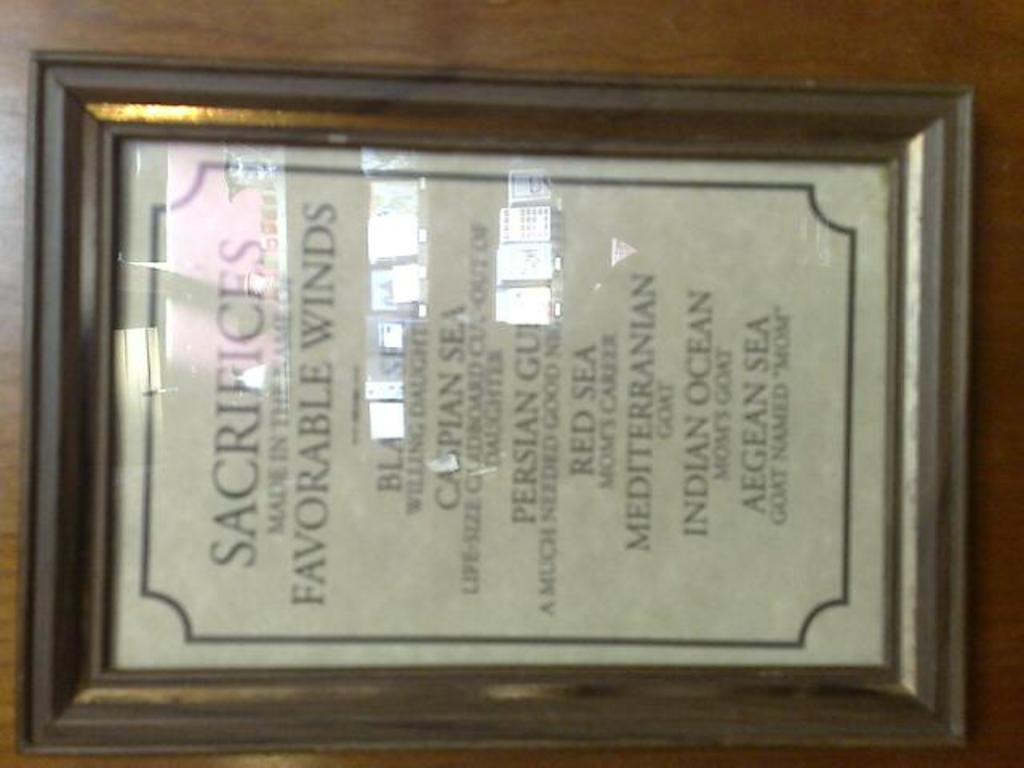<image>
Render a clear and concise summary of the photo. a framed picture that says sacrifices on it 